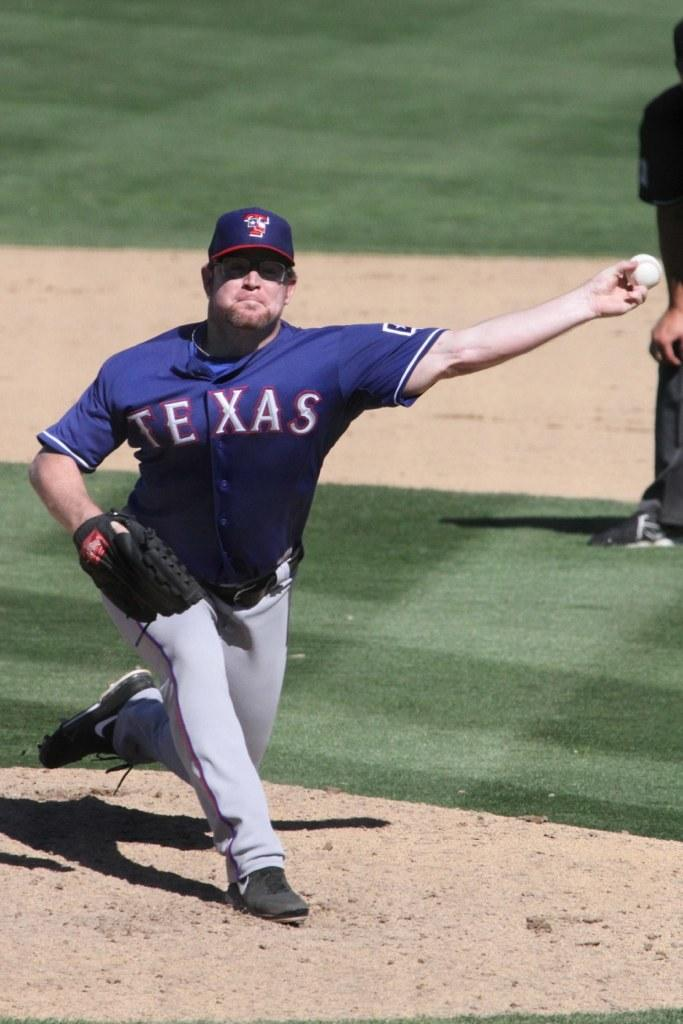Provide a one-sentence caption for the provided image. A pitcher for a Texas team throwing a baseball. 